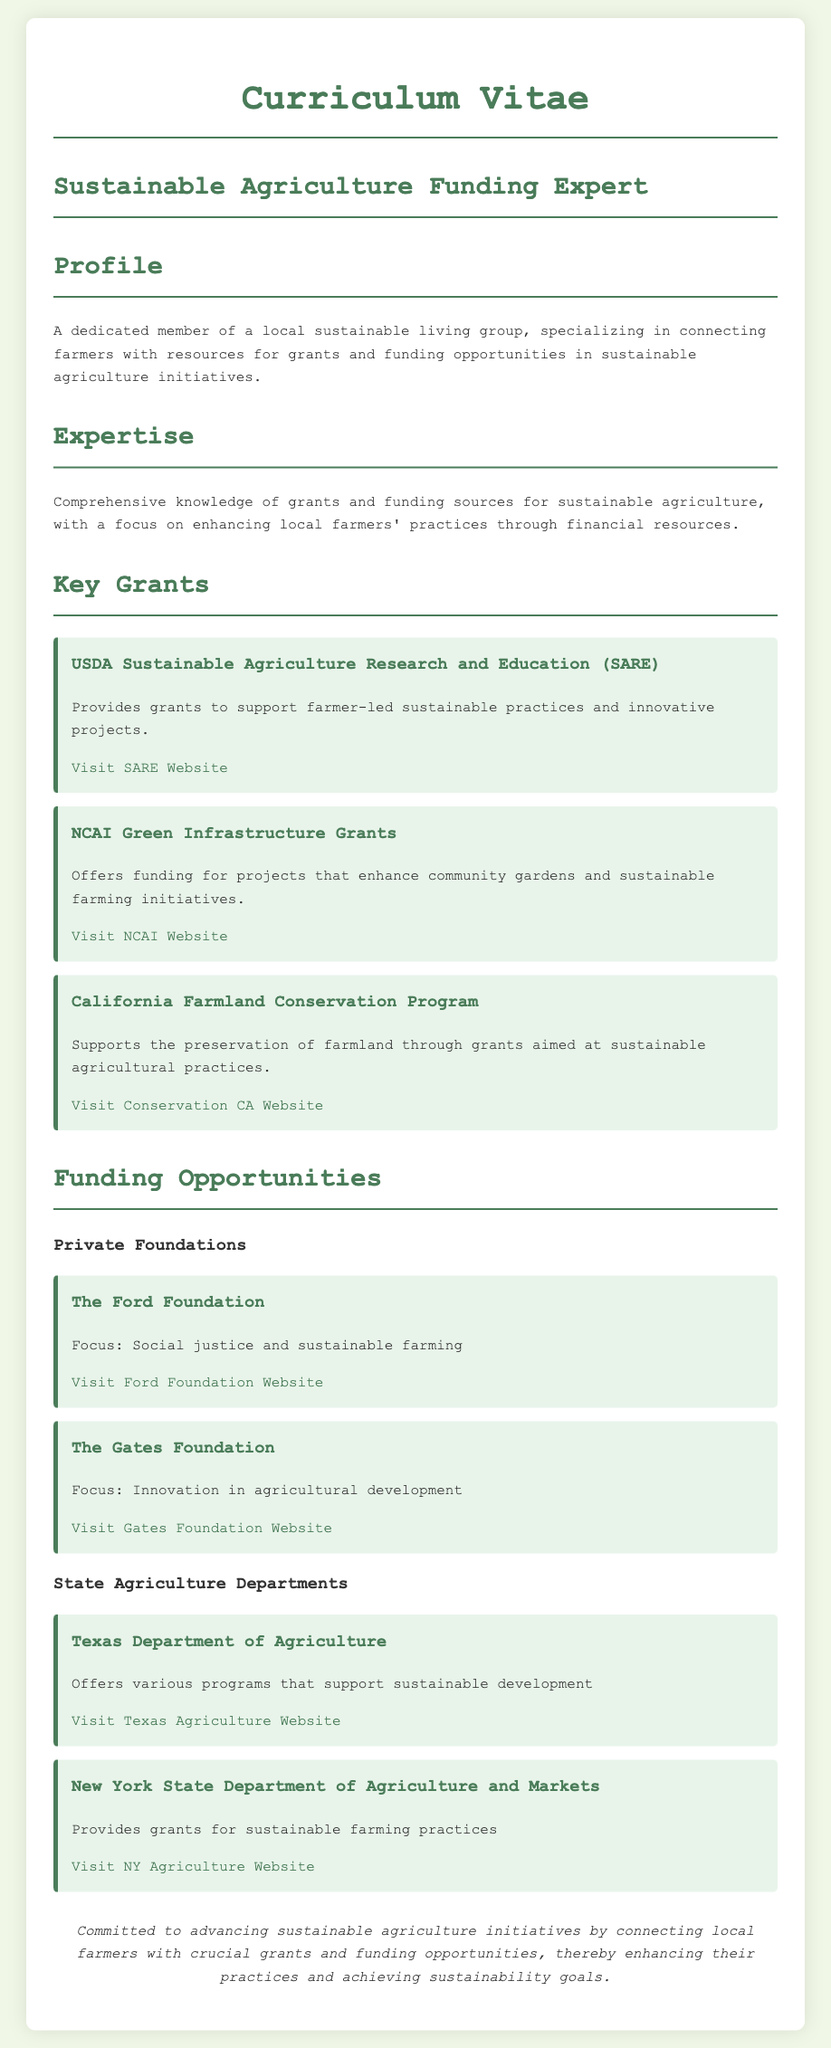what is the focus of the Ford Foundation? The Ford Foundation focuses on social justice and sustainable farming, as stated in the document.
Answer: Social justice and sustainable farming what is the name of the program that supports farmer-led sustainable practices? The program that supports farmer-led sustainable practices is called USDA Sustainable Agriculture Research and Education (SARE).
Answer: USDA Sustainable Agriculture Research and Education (SARE) how many private foundations are mentioned in the document? The document mentions two private foundations: The Ford Foundation and The Gates Foundation.
Answer: Two what is the objective of the California Farmland Conservation Program? The objective of the California Farmland Conservation Program is to support the preservation of farmland through grants aimed at sustainable agricultural practices.
Answer: Preservation of farmland what type of organizations are listed under "State Agriculture Departments"? The organizations listed under "State Agriculture Departments" are specific state agriculture departments, such as Texas Department of Agriculture and New York State Department of Agriculture and Markets.
Answer: State agriculture departments which foundation focuses on innovation in agricultural development? The foundation that focuses on innovation in agricultural development is The Gates Foundation.
Answer: The Gates Foundation how is the individual's expertise described in the CV? The individual's expertise is described as comprehensive knowledge of grants and funding sources for sustainable agriculture.
Answer: Comprehensive knowledge of grants and funding sources what is the ultimate goal of the individual in connecting farmers with grants? The ultimate goal is to enhance farmers' practices and achieve sustainability goals through connecting them with funding opportunities.
Answer: Enhance farmers' practices and achieve sustainability goals 